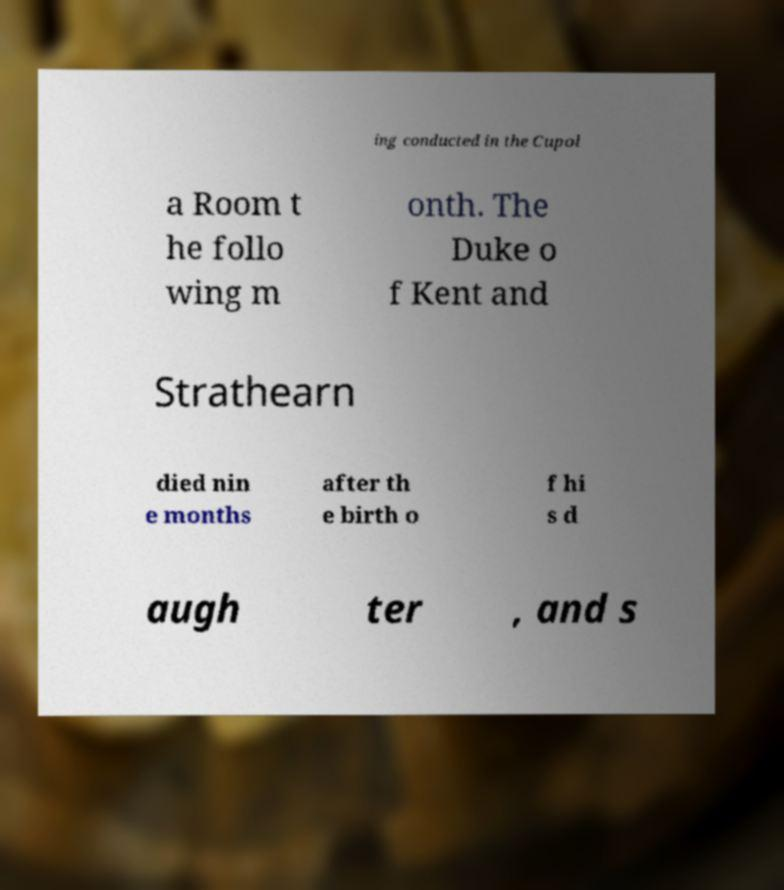I need the written content from this picture converted into text. Can you do that? ing conducted in the Cupol a Room t he follo wing m onth. The Duke o f Kent and Strathearn died nin e months after th e birth o f hi s d augh ter , and s 